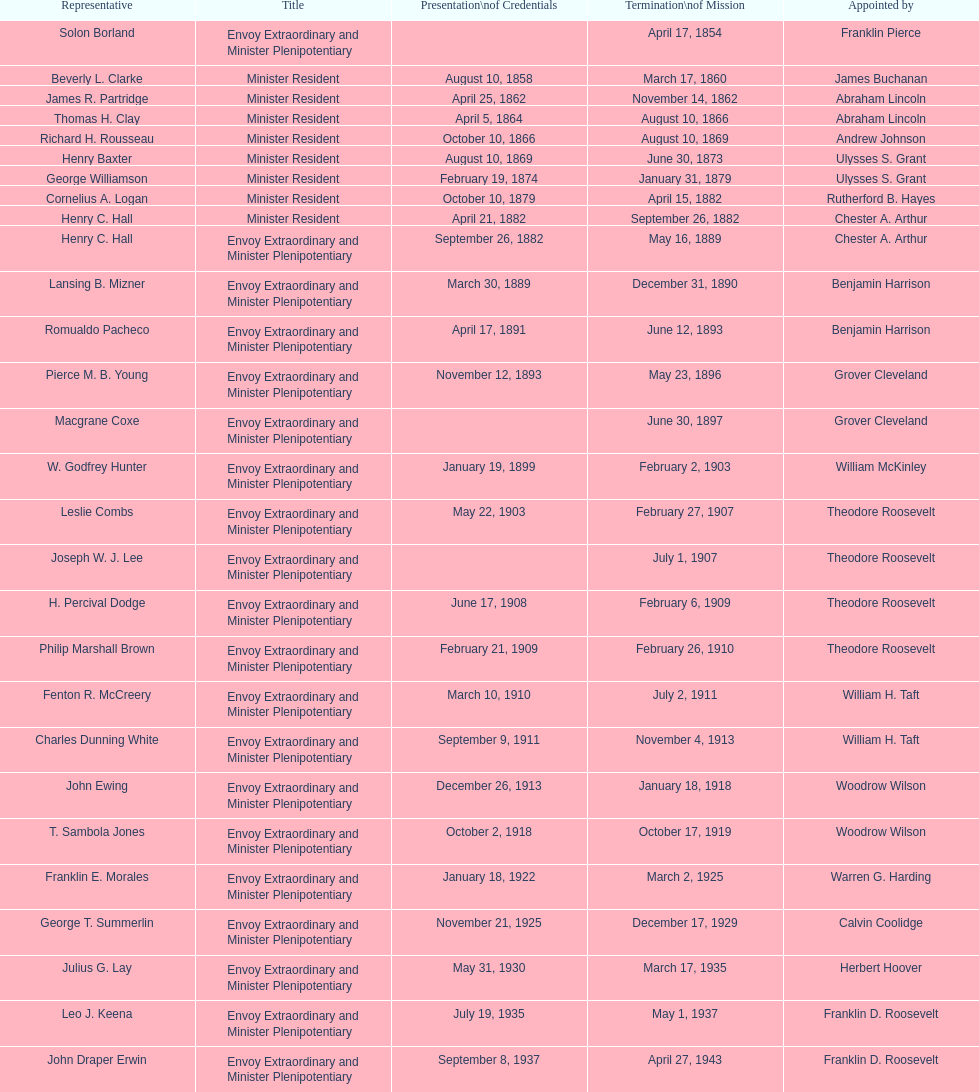What was the period, in years, of leslie combs' term? 4 years. 